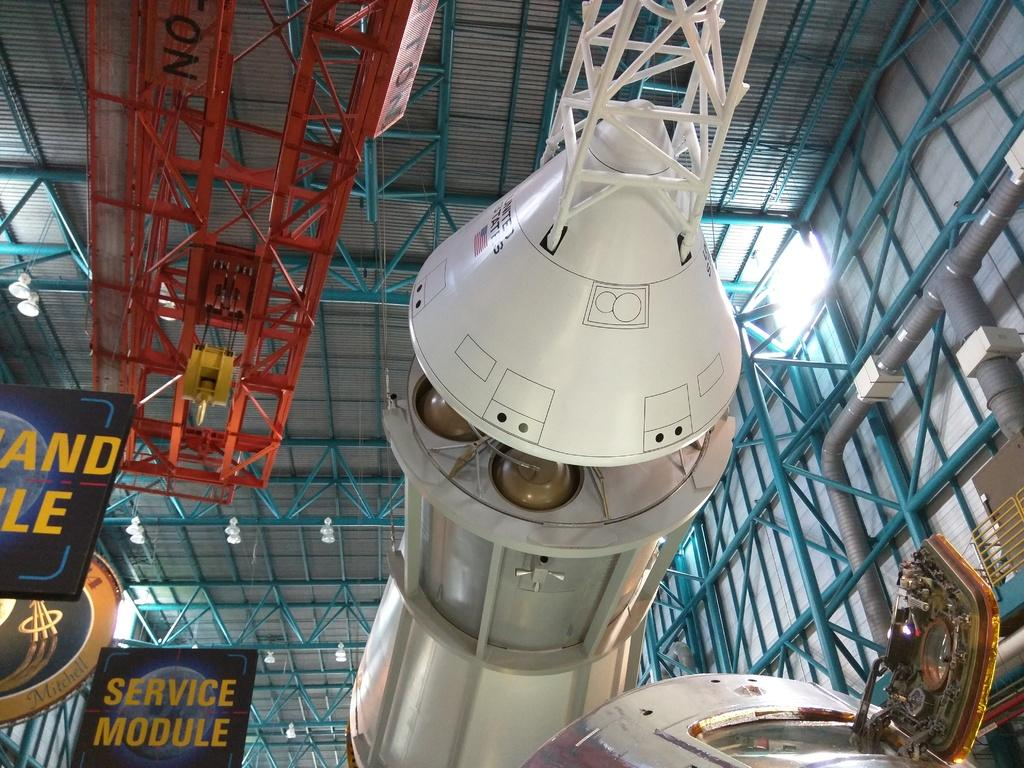<image>
Write a terse but informative summary of the picture. A looking up view at the service module of a spacecraft in a museums hangar. 